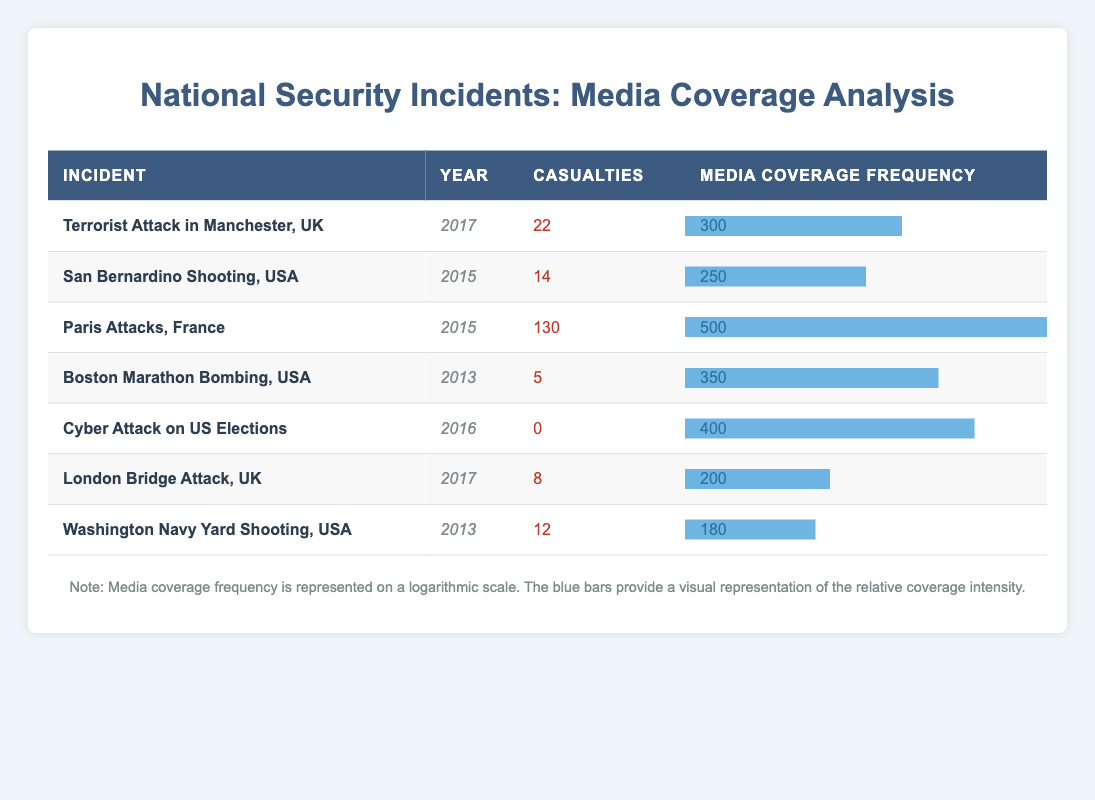What is the incident with the highest media coverage frequency? The table indicates that the "Paris Attacks, France" incident has the highest media coverage frequency at 500.
Answer: Paris Attacks, France Which incident resulted in the least number of casualties? The table shows that the "Boston Marathon Bombing, USA" resulted in the least number of casualties, with 5 people affected.
Answer: Boston Marathon Bombing, USA What is the total number of casualties from all incidents listed? To find the total casualties, we sum the values: 22 + 14 + 130 + 5 + 0 + 8 + 12 = 191. Thus, the total number of casualties is 191.
Answer: 191 Is the media coverage frequency for the "San Bernardino Shooting, USA" higher than that for "London Bridge Attack, UK"? The media coverage frequency for the San Bernardino Shooting is 250, while for the London Bridge Attack, it is 200. Since 250 is greater than 200, the statement is true.
Answer: Yes What is the average media coverage frequency of incidents in 2017? There are two incidents in 2017: "Terrorist Attack in Manchester, UK" (300) and "London Bridge Attack, UK" (200). The sum of these frequencies is 300 + 200 = 500. To find the average, we divide by the number of incidents: 500 / 2 = 250.
Answer: 250 Which year had the highest total casualties from incidents? Calculate the total casualties for each year: 2013 (5 + 12 = 17), 2015 (14 + 130 = 144), 2016 (0), and 2017 (22 + 8 = 30). The highest total casualties are in 2015 with 144.
Answer: 2015 Was there a national security incident in 2016 that resulted in casualties? The incident listed for 2016 is the "Cyber Attack on US Elections," which reports 0 casualties. Thus, there were no casualties in 2016.
Answer: No What percentage of casualties did the "Paris Attacks, France" account for based on total casualties? The "Paris Attacks" had 130 casualties, and the total casualties across all incidents is 191. To calculate the percentage: (130 / 191) * 100 ≈ 68.02%. Thus, it accounted for approximately 68.02% of total casualties.
Answer: 68.02% 